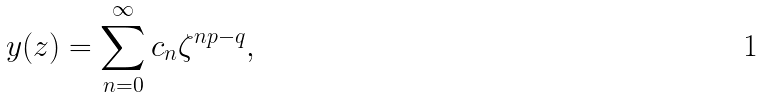<formula> <loc_0><loc_0><loc_500><loc_500>y ( z ) = \sum _ { n = 0 } ^ { \infty } c _ { n } \zeta ^ { n p - q } ,</formula> 